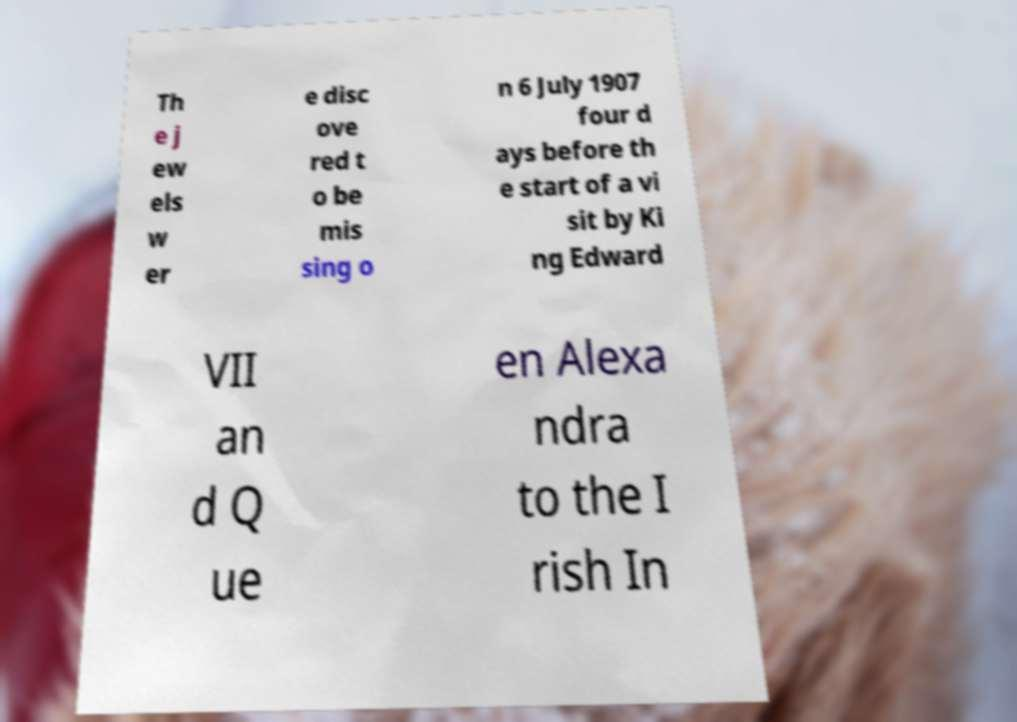Please read and relay the text visible in this image. What does it say? Th e j ew els w er e disc ove red t o be mis sing o n 6 July 1907 four d ays before th e start of a vi sit by Ki ng Edward VII an d Q ue en Alexa ndra to the I rish In 